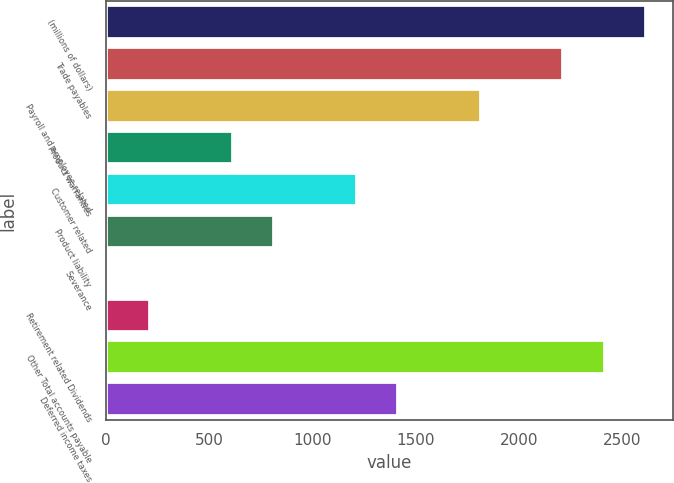Convert chart to OTSL. <chart><loc_0><loc_0><loc_500><loc_500><bar_chart><fcel>(millions of dollars)<fcel>Trade payables<fcel>Payroll and employee related<fcel>Product warranties<fcel>Customer related<fcel>Product liability<fcel>Severance<fcel>Retirement related Dividends<fcel>Other Total accounts payable<fcel>Deferred income taxes<nl><fcel>2613.51<fcel>2213.17<fcel>1812.83<fcel>611.81<fcel>1212.32<fcel>811.98<fcel>11.3<fcel>211.47<fcel>2413.34<fcel>1412.49<nl></chart> 